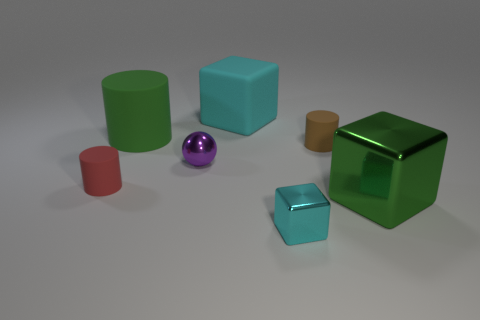Subtract all red rubber cylinders. How many cylinders are left? 2 Add 1 tiny purple metal cylinders. How many objects exist? 8 Subtract all red cylinders. How many cylinders are left? 2 Subtract 1 spheres. How many spheres are left? 0 Subtract all yellow balls. How many cyan cubes are left? 2 Add 1 cyan objects. How many cyan objects exist? 3 Subtract 1 red cylinders. How many objects are left? 6 Subtract all cylinders. How many objects are left? 4 Subtract all cyan balls. Subtract all red cylinders. How many balls are left? 1 Subtract all small rubber things. Subtract all small cylinders. How many objects are left? 3 